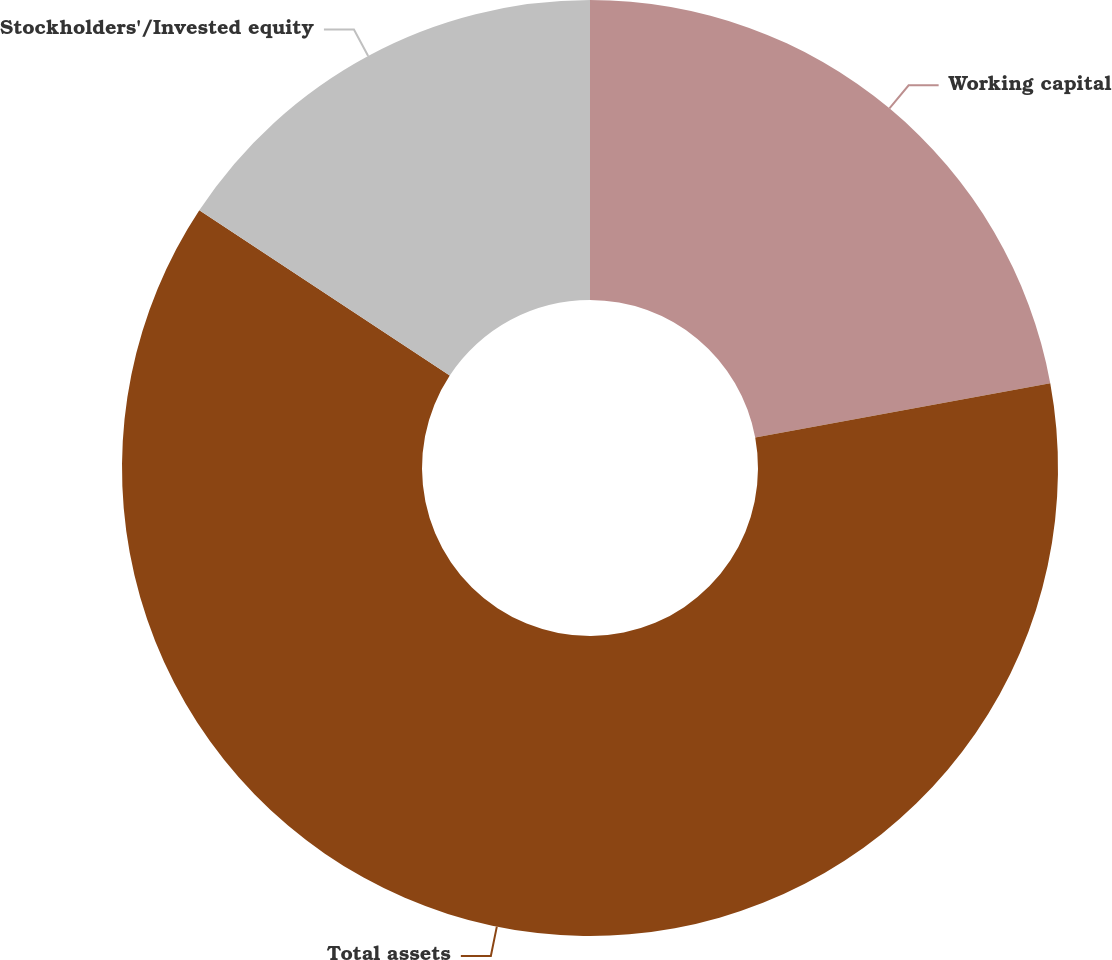Convert chart. <chart><loc_0><loc_0><loc_500><loc_500><pie_chart><fcel>Working capital<fcel>Total assets<fcel>Stockholders'/Invested equity<nl><fcel>22.1%<fcel>62.18%<fcel>15.72%<nl></chart> 